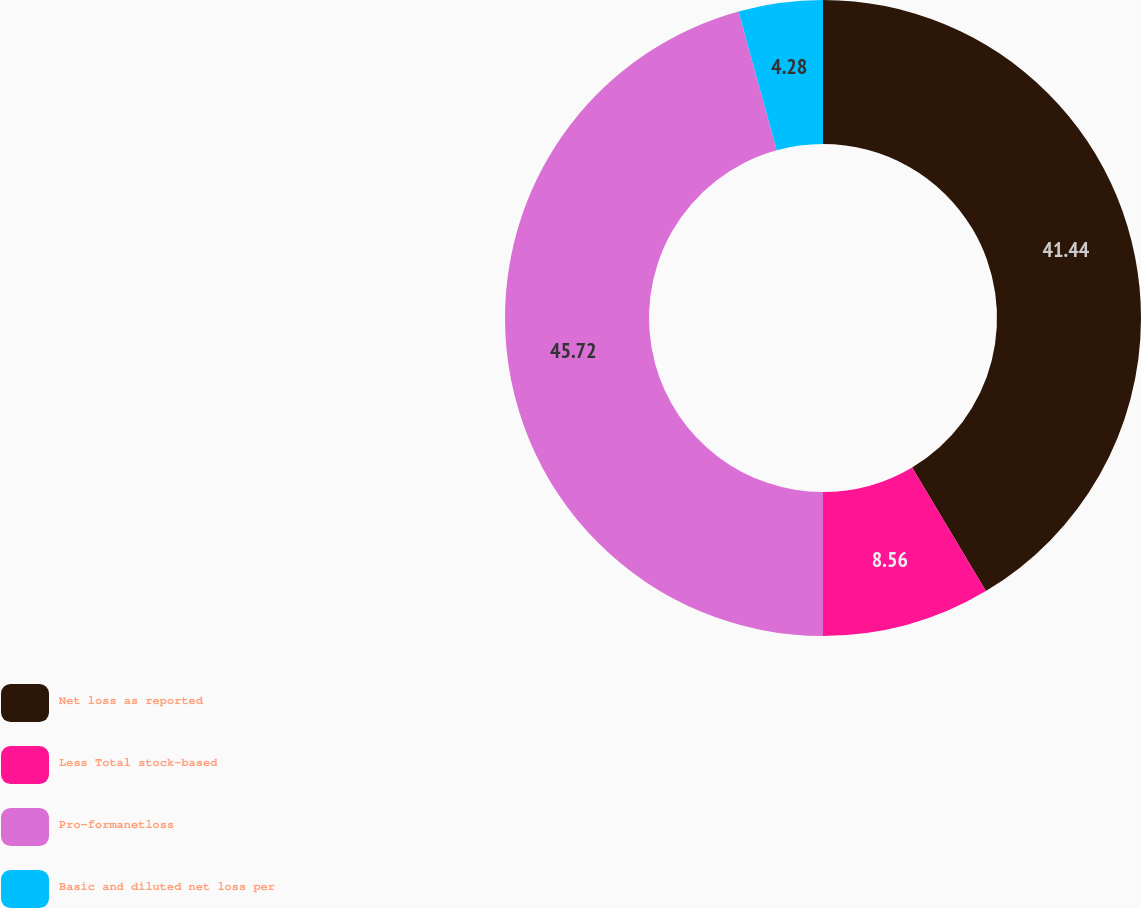Convert chart to OTSL. <chart><loc_0><loc_0><loc_500><loc_500><pie_chart><fcel>Net loss as reported<fcel>Less Total stock-based<fcel>Pro-formanetloss<fcel>Basic and diluted net loss per<nl><fcel>41.44%<fcel>8.56%<fcel>45.72%<fcel>4.28%<nl></chart> 